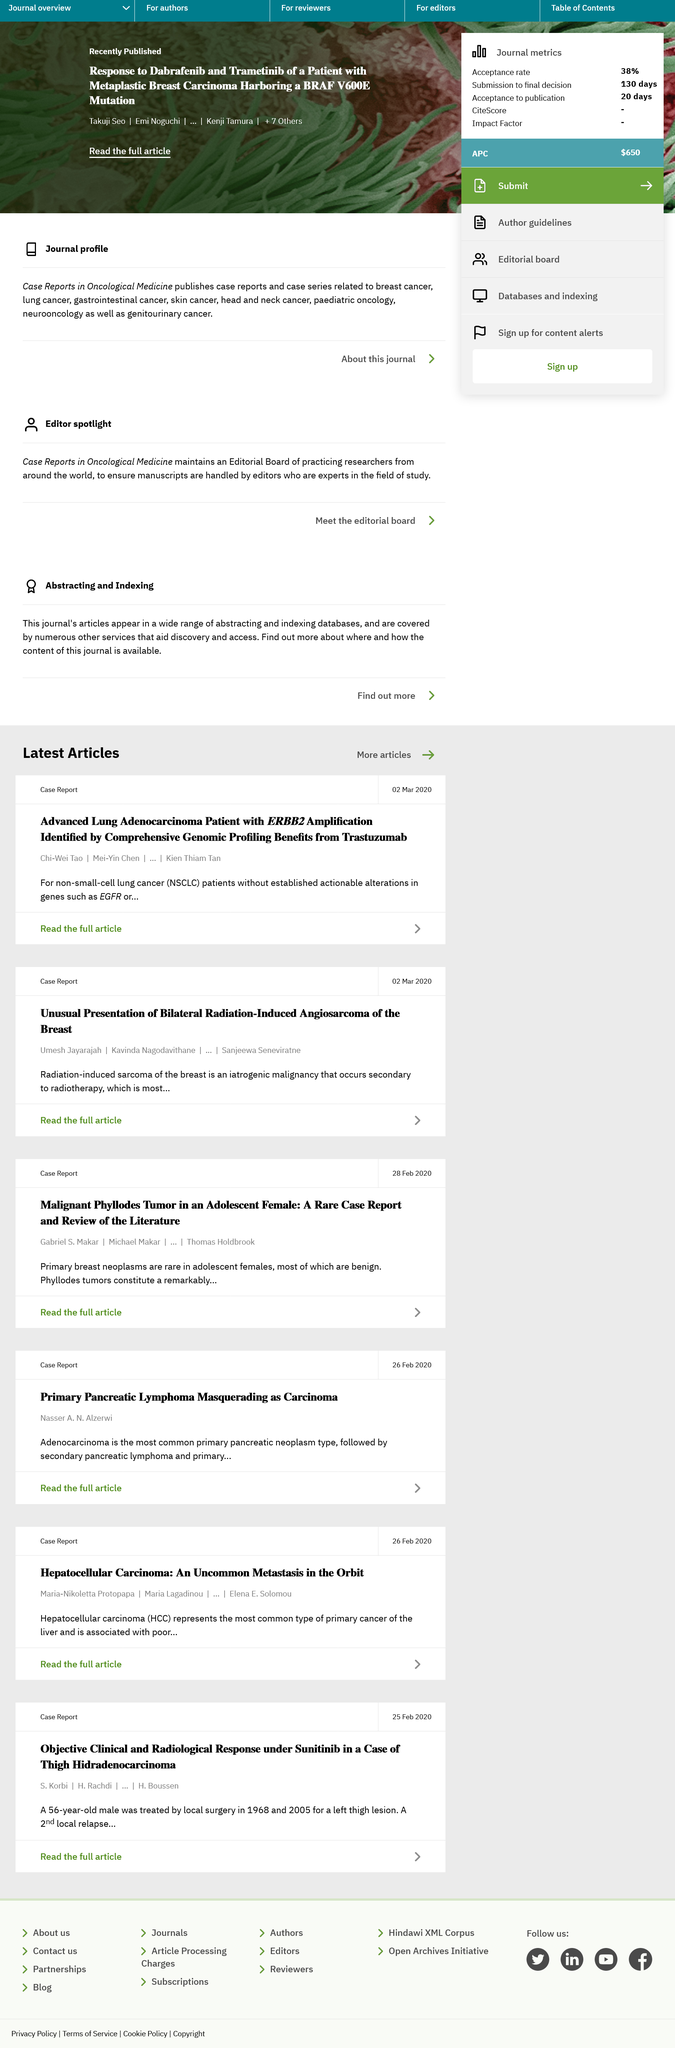Indicate a few pertinent items in this graphic. Non-small-cell lung cancer is a type of lung cancer that does not belong to the small cell lung cancer subtype. A radiation-induced sarcoma of the breast is a type of cancer that develops as a result of radiation therapy treatment and is considered an iatrogenic malignancy, which means it is caused by medical treatment. This case report was created on March 2nd, 2020. 